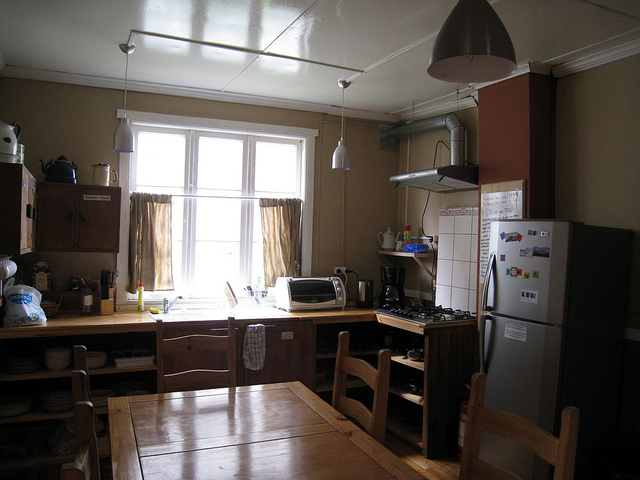<image>Is this a gas or electric stove? I am not sure if the stove is gas or electric. It could be either. Is this a gas or electric stove? I don't know if this is a gas or electric stove. It can be seen as both gas and electric. 